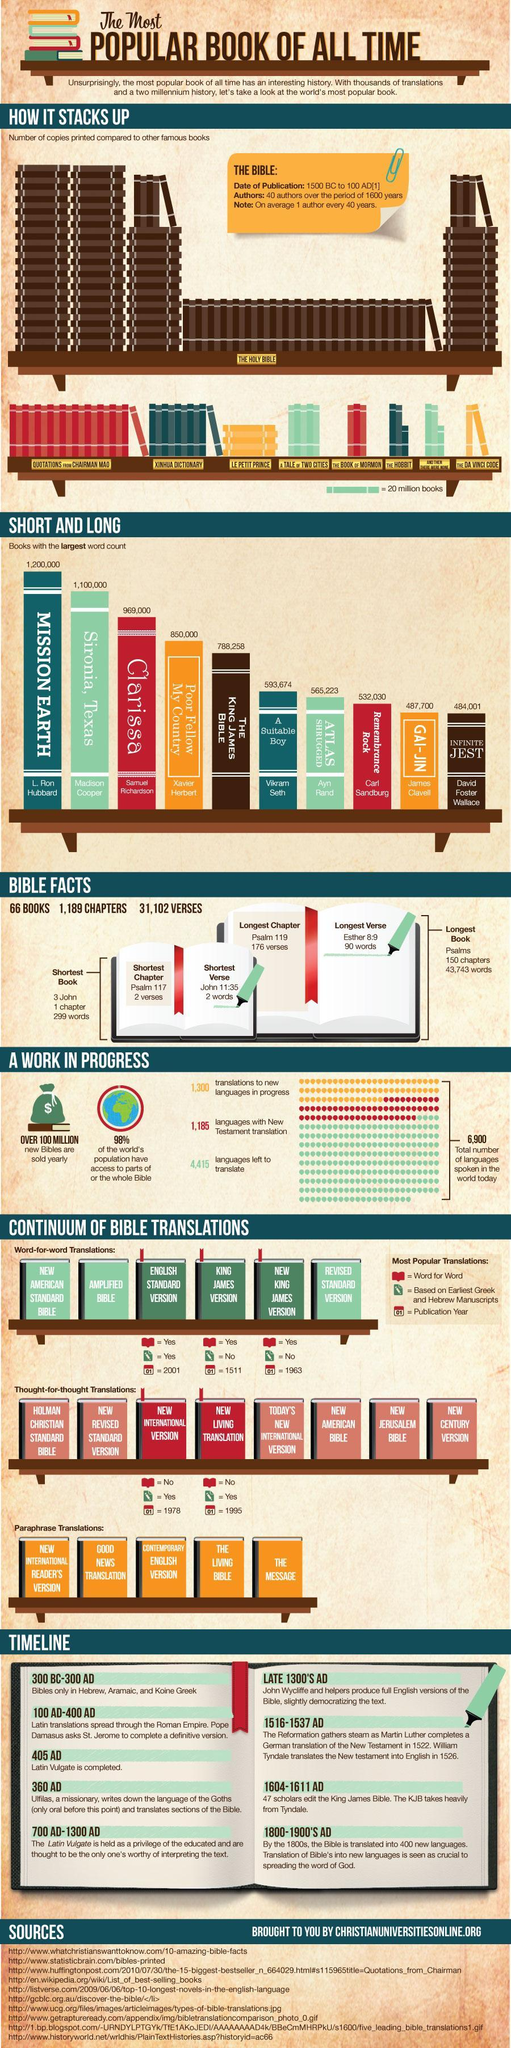Which is the shortest chapter of the Bible?
Answer the question with a short phrase. Psalm 117 Which book has the second-largest word count? Sironia, Texas Which is the longest book of the Bible? Psalms How many words are there in the shortest book of the Bible? 299 words How many people wrote the Bible? 40 Which is the longest chapter of the Bible? Psalm 119 Which is the shortest verse in the Bible? John 11:35 Who is the author of 'Clarissa'? Samuel Richardson Which is the shortest book of the Bible? 3 John Which book has the largest word count? MISSION EARTH 